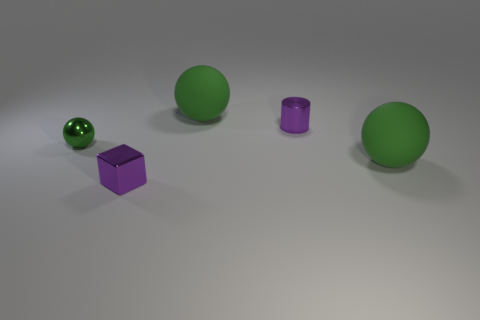Subtract 1 spheres. How many spheres are left? 2 Add 4 metal objects. How many objects exist? 9 Subtract all purple spheres. Subtract all green cylinders. How many spheres are left? 3 Subtract all cylinders. How many objects are left? 4 Subtract all tiny cylinders. Subtract all tiny things. How many objects are left? 1 Add 3 tiny purple shiny things. How many tiny purple shiny things are left? 5 Add 1 small gray rubber balls. How many small gray rubber balls exist? 1 Subtract 1 purple cylinders. How many objects are left? 4 